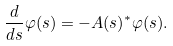<formula> <loc_0><loc_0><loc_500><loc_500>\frac { d } { d s } \varphi ( s ) = - A ( s ) ^ { * } \varphi ( s ) .</formula> 